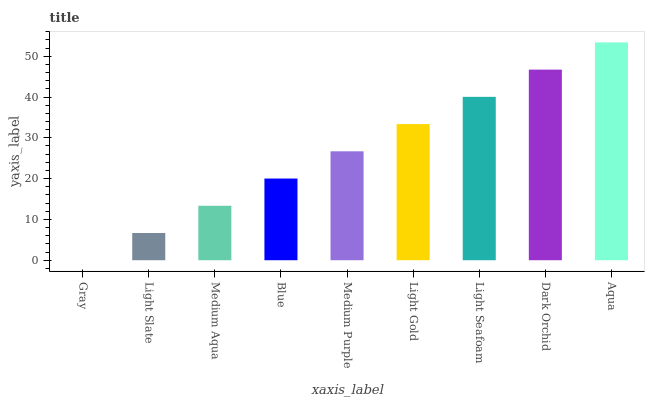Is Gray the minimum?
Answer yes or no. Yes. Is Aqua the maximum?
Answer yes or no. Yes. Is Light Slate the minimum?
Answer yes or no. No. Is Light Slate the maximum?
Answer yes or no. No. Is Light Slate greater than Gray?
Answer yes or no. Yes. Is Gray less than Light Slate?
Answer yes or no. Yes. Is Gray greater than Light Slate?
Answer yes or no. No. Is Light Slate less than Gray?
Answer yes or no. No. Is Medium Purple the high median?
Answer yes or no. Yes. Is Medium Purple the low median?
Answer yes or no. Yes. Is Light Seafoam the high median?
Answer yes or no. No. Is Medium Aqua the low median?
Answer yes or no. No. 